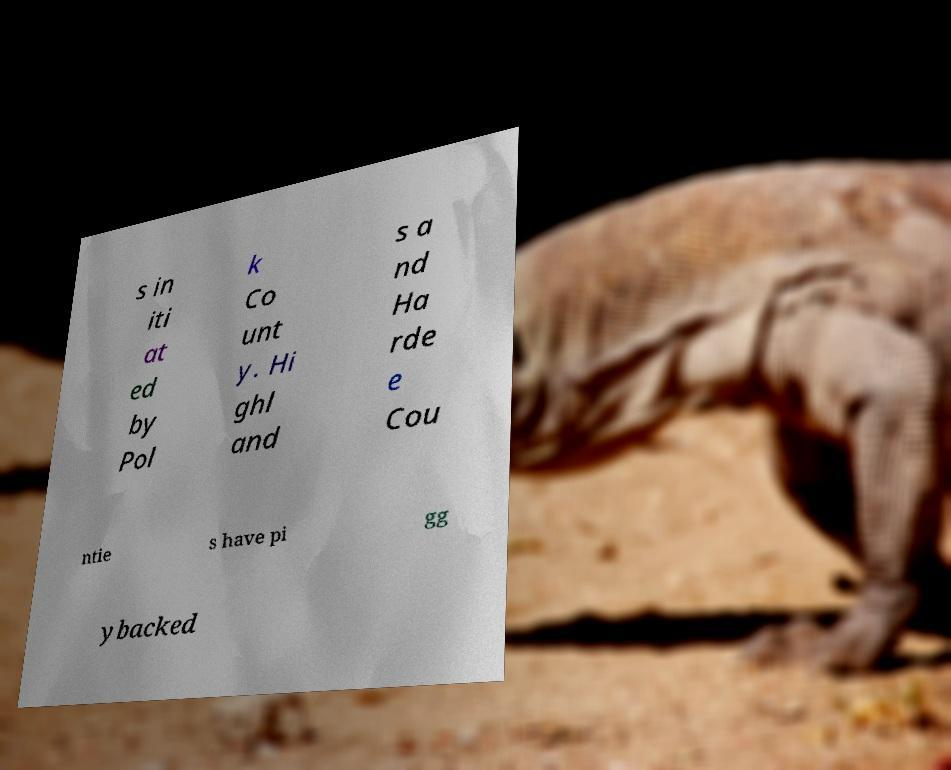Please read and relay the text visible in this image. What does it say? s in iti at ed by Pol k Co unt y. Hi ghl and s a nd Ha rde e Cou ntie s have pi gg ybacked 